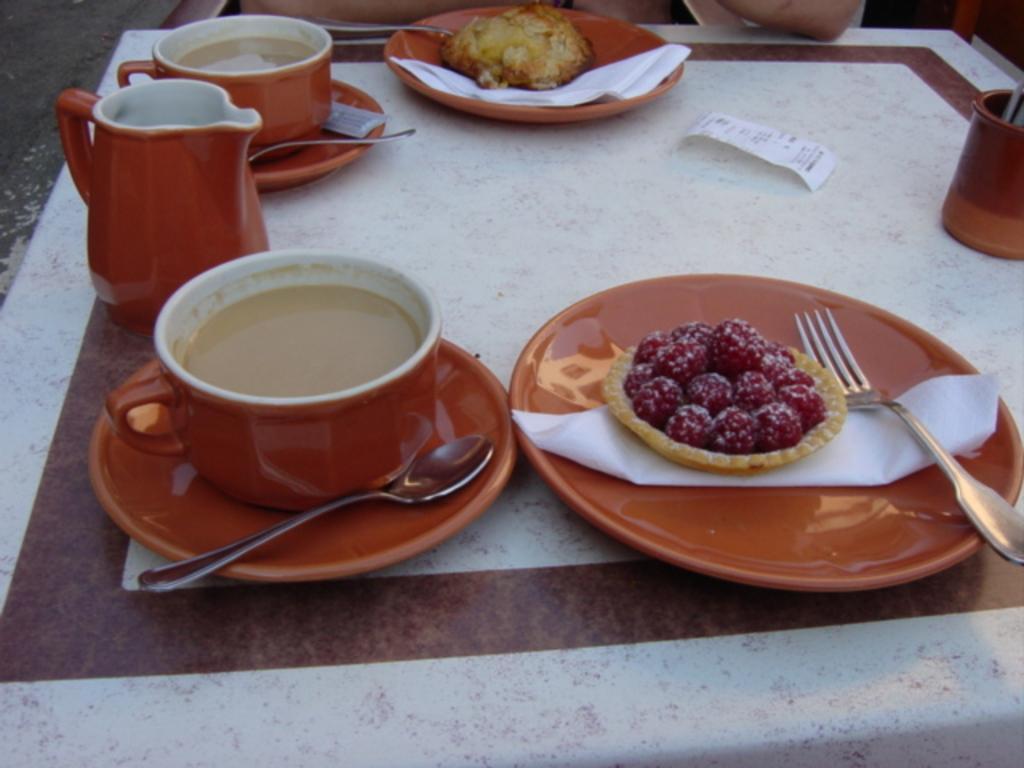Describe this image in one or two sentences. In this image I can see a plate with food,cup with saucer,jug,spoons,forks,and the tissues. And these plates are in orange color and there is a food with red color. These are on the table. And I can see persons hands on the table. 